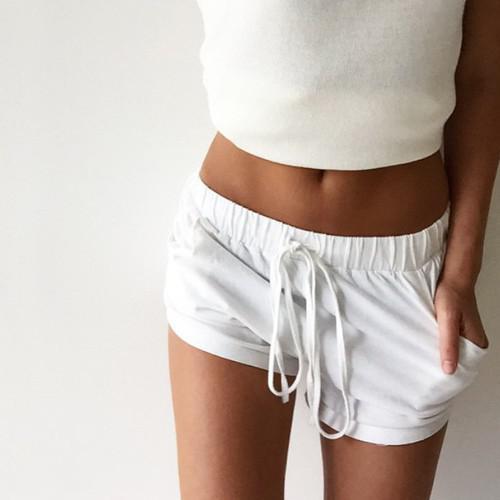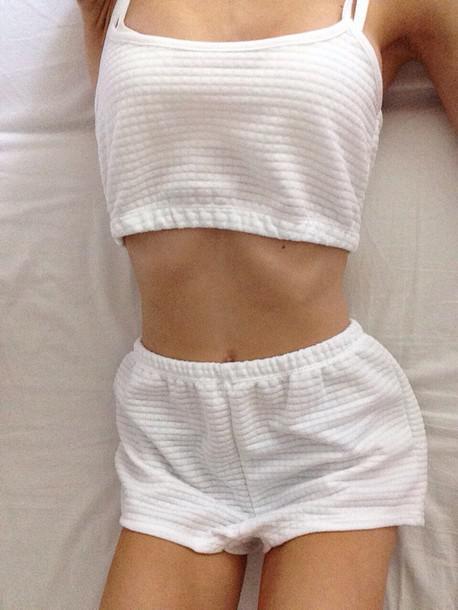The first image is the image on the left, the second image is the image on the right. Considering the images on both sides, is "One model is blonde and wears something made of satiny, shiny material, while the other model wears shorts with a short-sleeved top that doesn't bare her midriff." valid? Answer yes or no. No. The first image is the image on the left, the second image is the image on the right. Given the left and right images, does the statement "A pajama set is a pair of short pants paired with a t-shirt top with short sleeves and design printed on the front." hold true? Answer yes or no. No. 